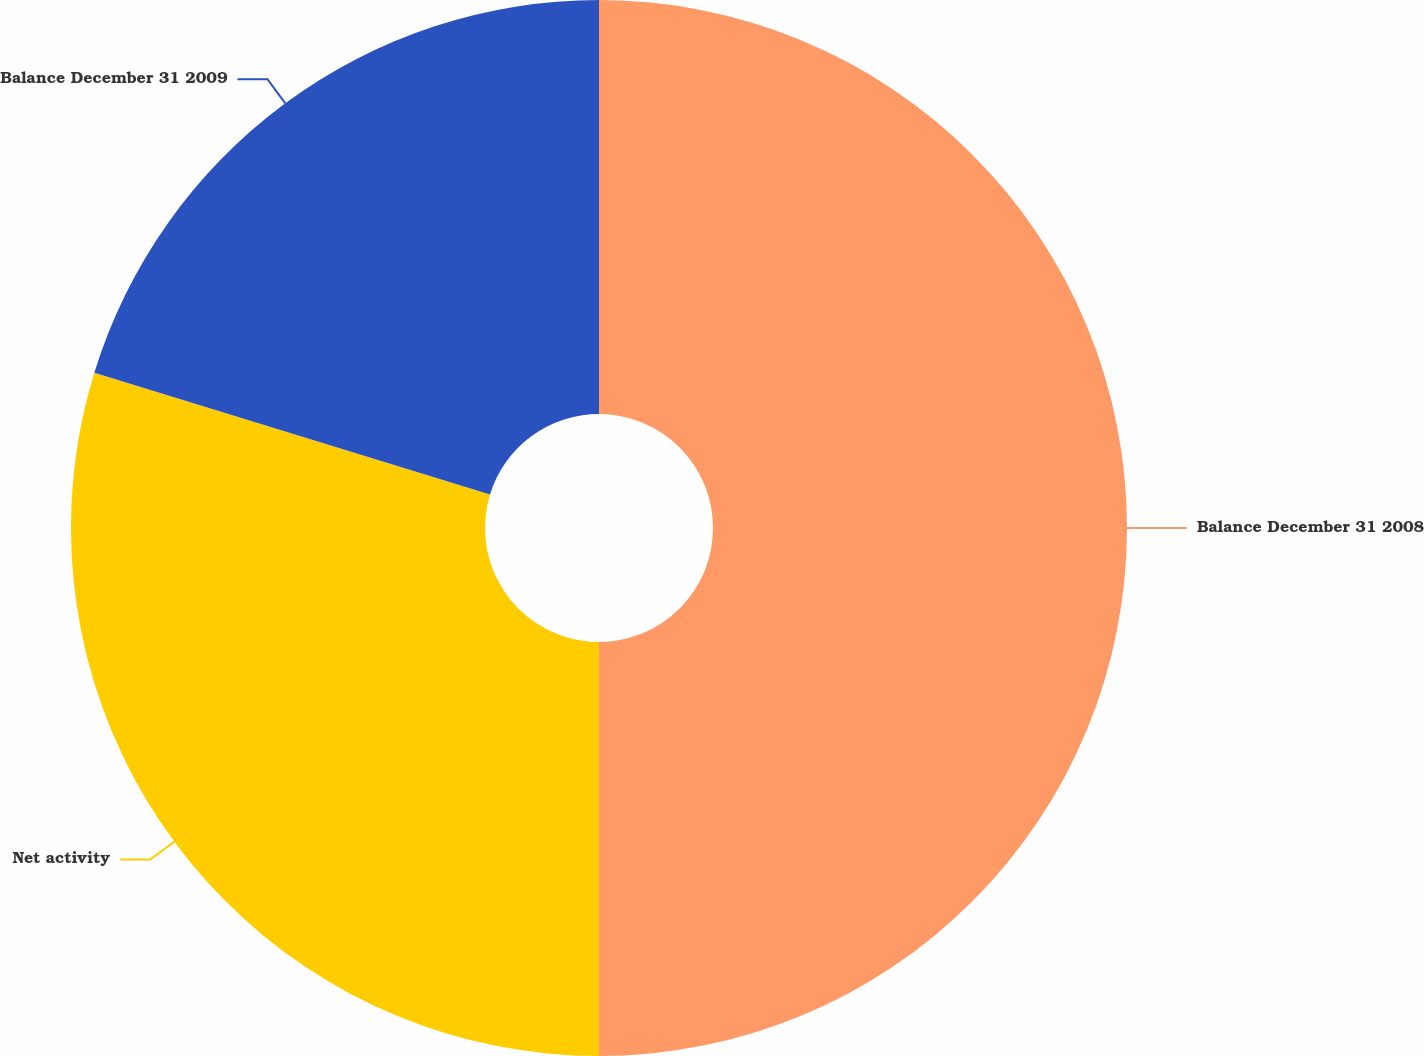Convert chart. <chart><loc_0><loc_0><loc_500><loc_500><pie_chart><fcel>Balance December 31 2008<fcel>Net activity<fcel>Balance December 31 2009<nl><fcel>50.0%<fcel>29.75%<fcel>20.25%<nl></chart> 